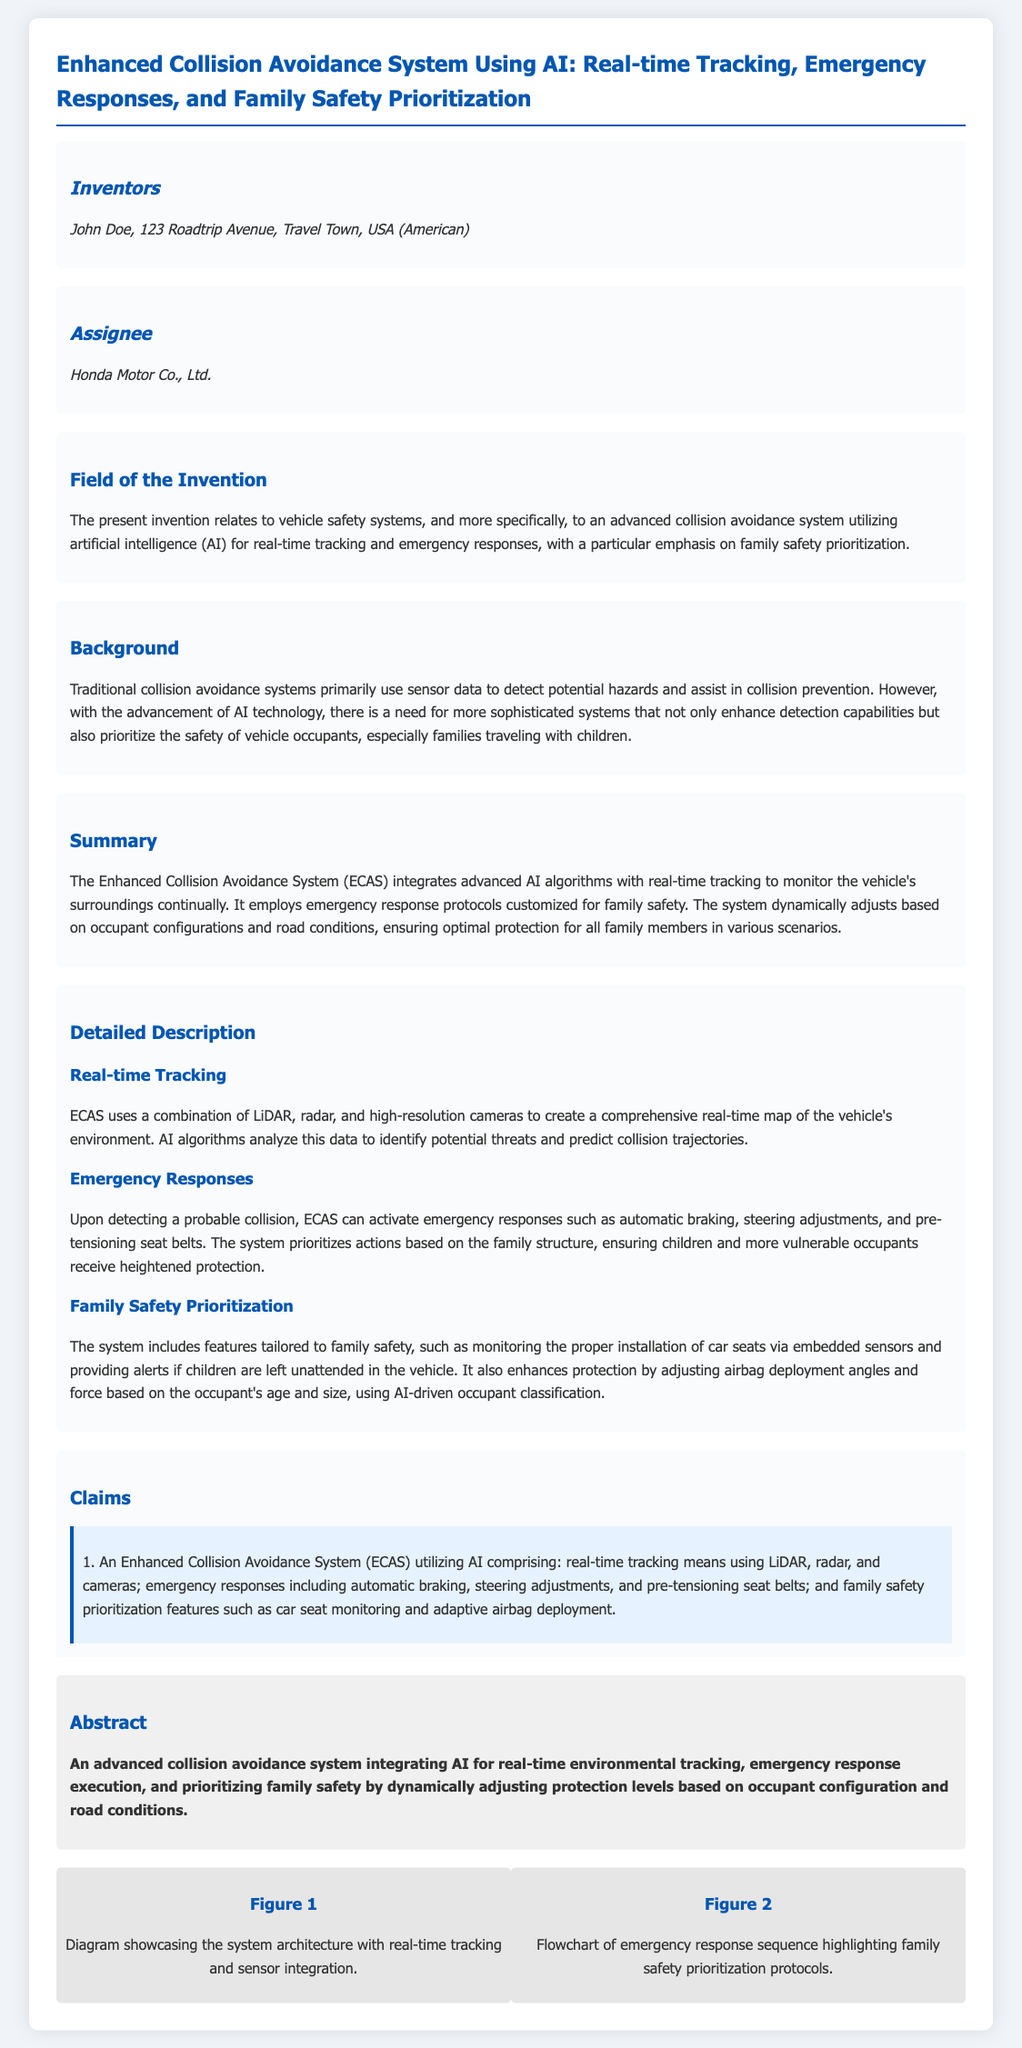What is the title of the patent application? The title of the patent application is indicated at the top of the document.
Answer: Enhanced Collision Avoidance System Using AI: Real-time Tracking, Emergency Responses, and Family Safety Prioritization Who is the inventor? The inventor is mentioned in the section dedicated to inventors in the document.
Answer: John Doe What is the assignee of the patent? The assignee is the entity that holds the rights to the patent, as stated in the assignee section.
Answer: Honda Motor Co., Ltd What types of technology does the Enhanced Collision Avoidance System utilize? The system's technology is outlined in various sections, specifically under detailed descriptions of its components.
Answer: LiDAR, radar, and high-resolution cameras What primary function does the system provide during an emergency? The system's emergency functions are detailed under the emergency responses section.
Answer: Automatic braking How does the system enhance family safety? Family safety features are explicitly mentioned in the section discussing family safety prioritization.
Answer: Monitoring the proper installation of car seats What does the abstract highlight about the system's safety features? The abstract summarizes the key aspects of the system's operation and its focus areas.
Answer: Prioritizing family safety What is the focus of the field of invention? The field of invention defines the overarching theme and area addressed by the patent.
Answer: Vehicle safety systems On how many inventors are listed in this application? The number of inventors is found in the inventors section and can be directly counted from it.
Answer: One 